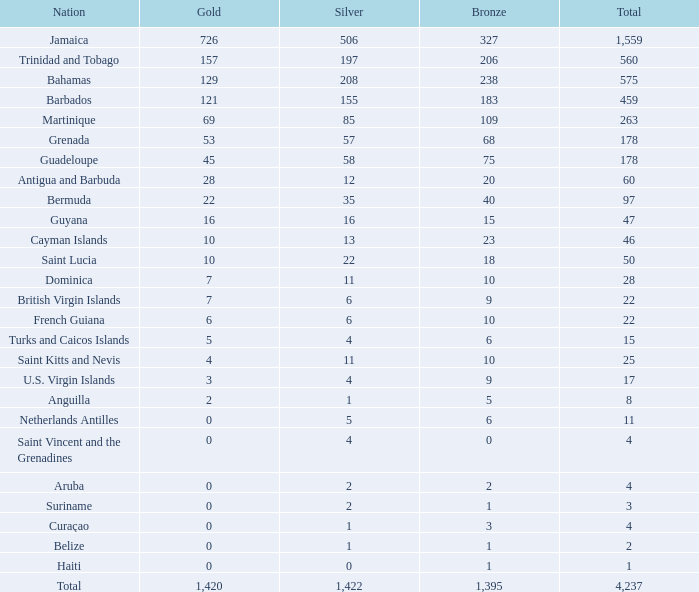What Nation has a Bronze that is smaller than 10 with a Silver of 5? Netherlands Antilles. 